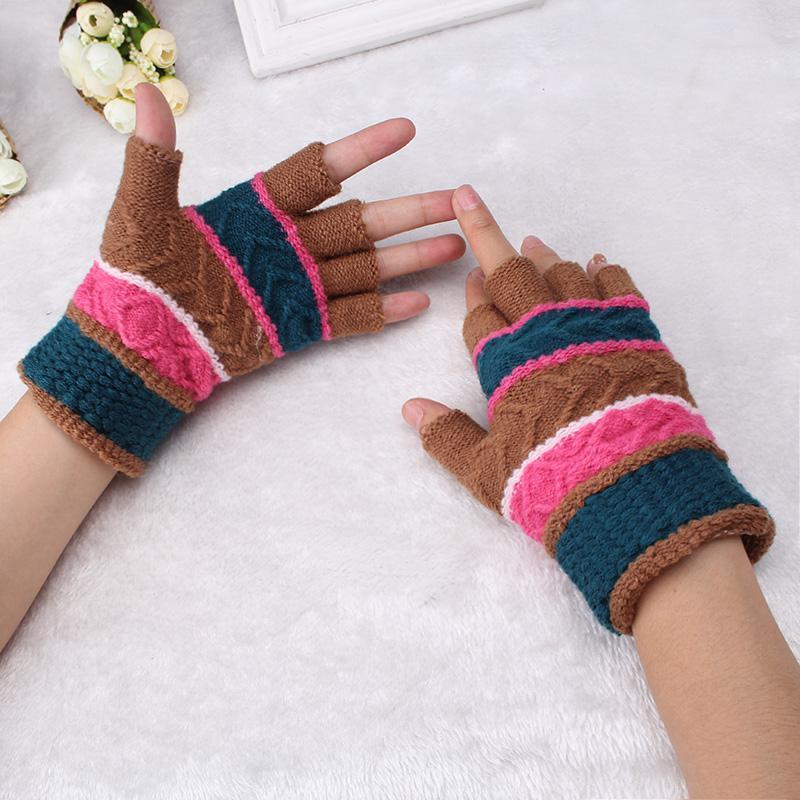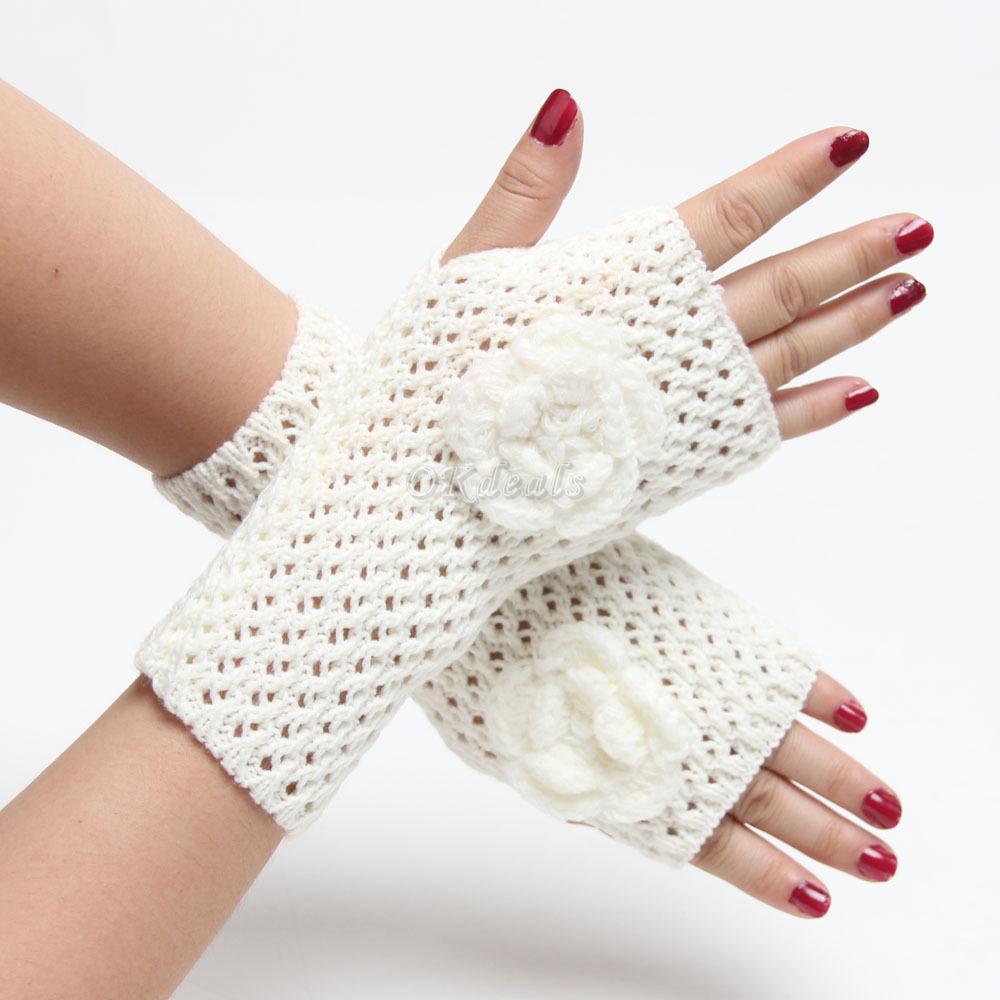The first image is the image on the left, the second image is the image on the right. Assess this claim about the two images: "There's a set of gloves that are not being worn.". Correct or not? Answer yes or no. No. The first image is the image on the left, the second image is the image on the right. Analyze the images presented: Is the assertion "There are a total of 2 hand models present wearing gloves." valid? Answer yes or no. Yes. 